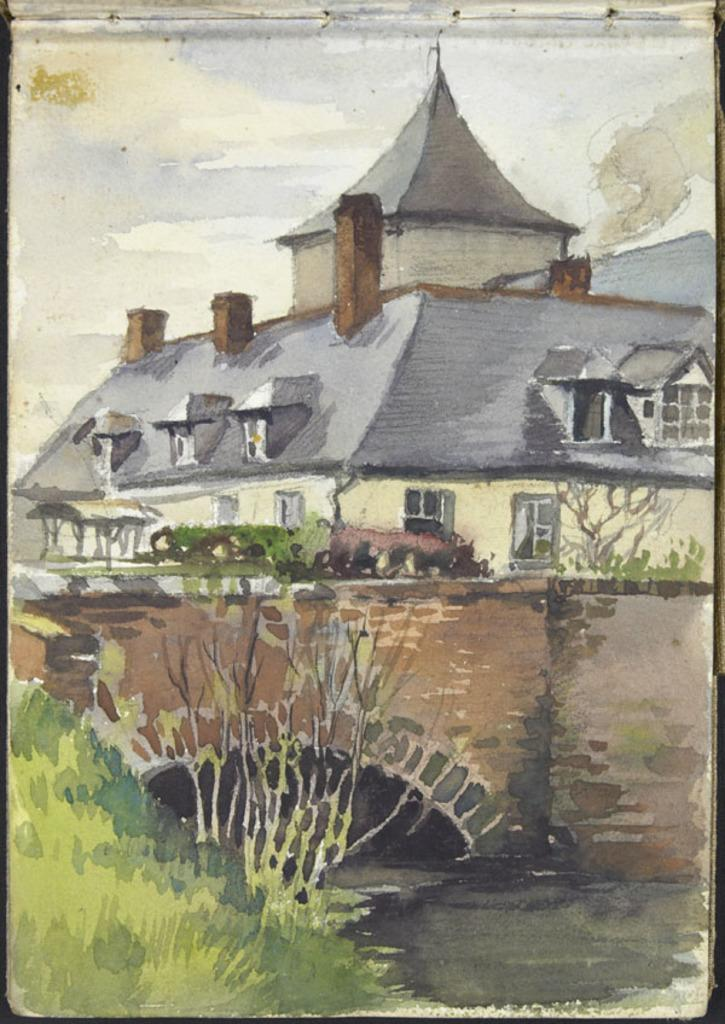What type of artwork is depicted in the image? The image is a painting. What structures can be seen in the painting? There is a building and a bridge in the painting. What type of vegetation is present in the painting? There are trees in the painting. What type of ground cover is on the left side of the painting? There is grass on the left side of the painting. What is the rate of the toy's movement in the painting? There is no toy present in the painting, so it is not possible to determine the rate of its movement. 